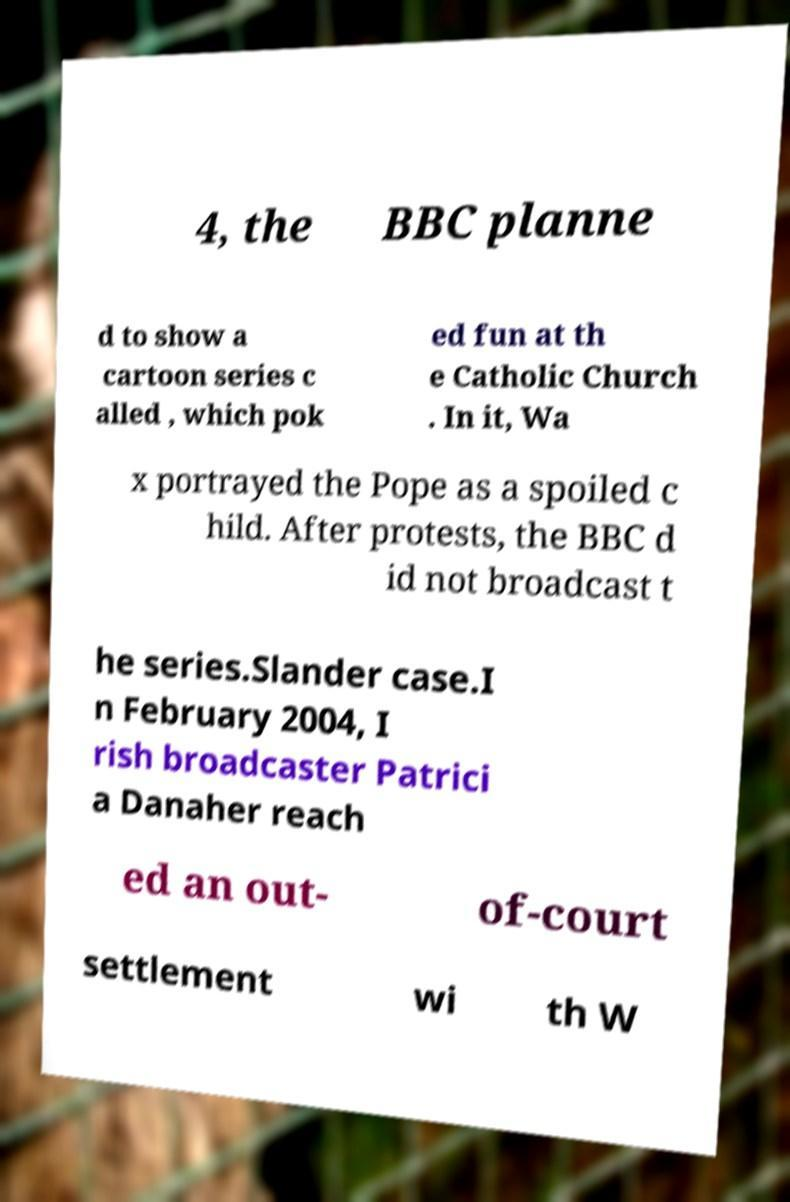Could you extract and type out the text from this image? 4, the BBC planne d to show a cartoon series c alled , which pok ed fun at th e Catholic Church . In it, Wa x portrayed the Pope as a spoiled c hild. After protests, the BBC d id not broadcast t he series.Slander case.I n February 2004, I rish broadcaster Patrici a Danaher reach ed an out- of-court settlement wi th W 